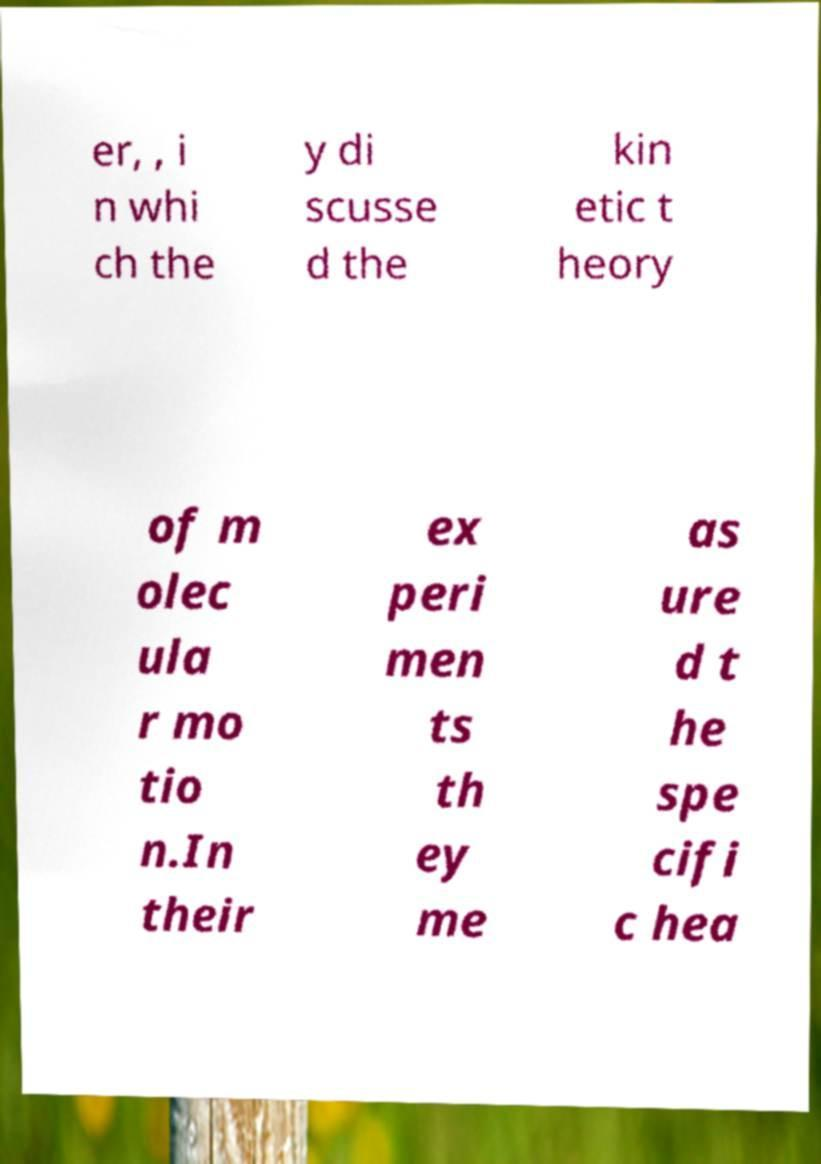Could you extract and type out the text from this image? er, , i n whi ch the y di scusse d the kin etic t heory of m olec ula r mo tio n.In their ex peri men ts th ey me as ure d t he spe cifi c hea 